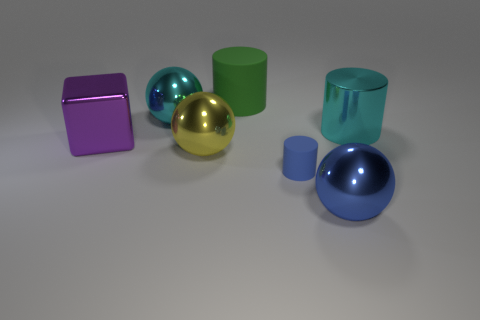What number of small things are either blocks or cyan cylinders?
Keep it short and to the point. 0. The object that is on the right side of the big green cylinder and left of the blue metallic object has what shape?
Give a very brief answer. Cylinder. Does the purple thing have the same material as the tiny cylinder?
Your answer should be very brief. No. The matte thing that is the same size as the cyan sphere is what color?
Your answer should be compact. Green. The object that is both to the right of the tiny matte cylinder and in front of the big yellow metallic object is what color?
Provide a short and direct response. Blue. There is a shiny thing that is the same color as the tiny matte cylinder; what is its size?
Provide a short and direct response. Large. What shape is the thing that is the same color as the large metal cylinder?
Your answer should be compact. Sphere. There is a object behind the large cyan thing that is left of the thing that is behind the cyan sphere; what size is it?
Your answer should be compact. Large. What is the material of the blue cylinder?
Make the answer very short. Rubber. Is the cyan cylinder made of the same material as the large cyan thing behind the metallic cylinder?
Provide a short and direct response. Yes. 